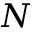Convert formula to latex. <formula><loc_0><loc_0><loc_500><loc_500>N</formula> 